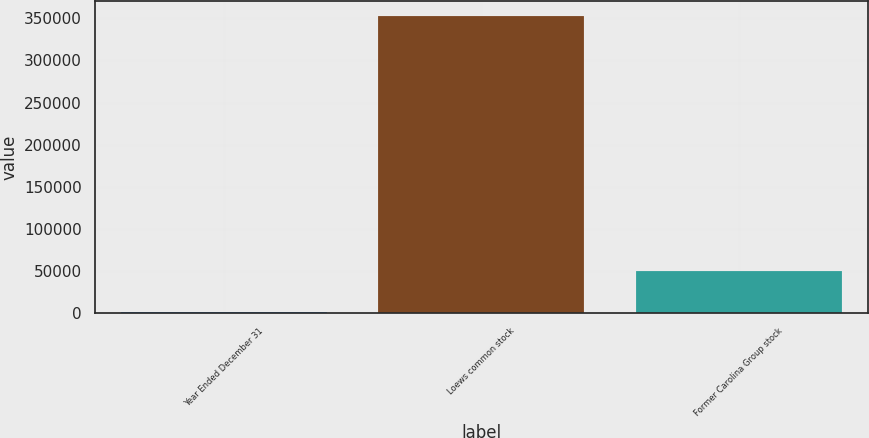<chart> <loc_0><loc_0><loc_500><loc_500><bar_chart><fcel>Year Ended December 31<fcel>Loews common stock<fcel>Former Carolina Group stock<nl><fcel>2007<fcel>352583<fcel>50684<nl></chart> 